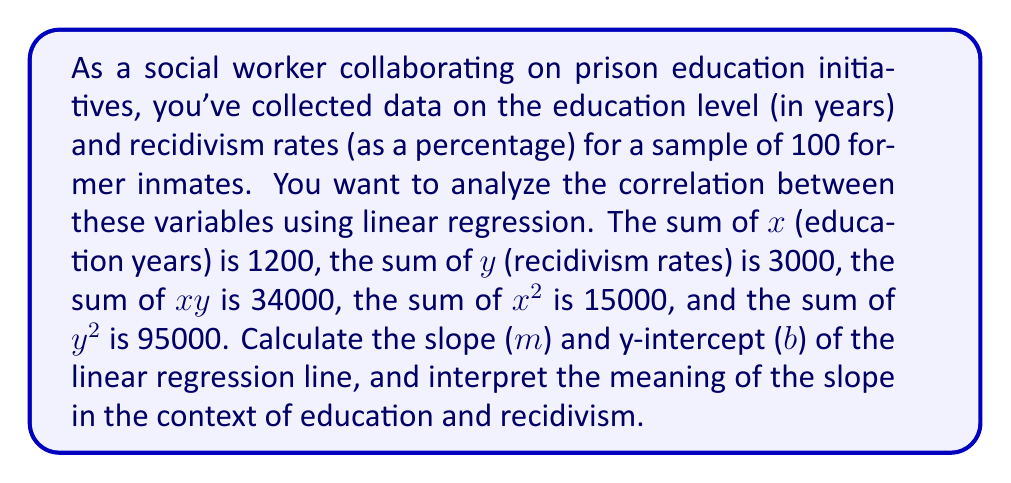Teach me how to tackle this problem. To find the slope (m) and y-intercept (b) of the linear regression line, we'll use the following formulas:

1. Slope (m):
   $$ m = \frac{n\sum xy - \sum x \sum y}{n\sum x^2 - (\sum x)^2} $$

2. Y-intercept (b):
   $$ b = \frac{\sum y - m\sum x}{n} $$

Where n is the number of data points (100 in this case).

Step 1: Calculate the slope (m)
$$ m = \frac{100(34000) - (1200)(3000)}{100(15000) - (1200)^2} $$
$$ m = \frac{3400000 - 3600000}{1500000 - 1440000} $$
$$ m = \frac{-200000}{60000} = -\frac{10}{3} \approx -3.33 $$

Step 2: Calculate the y-intercept (b)
$$ b = \frac{3000 - (-\frac{10}{3})(1200)}{100} $$
$$ b = \frac{3000 + 4000}{100} = \frac{7000}{100} = 70 $$

Interpretation of the slope:
The slope (m) represents the change in the recidivism rate for each additional year of education. In this case, the slope is negative, indicating an inverse relationship between education level and recidivism rate. Specifically, for each additional year of education, the recidivism rate is expected to decrease by approximately 3.33 percentage points.
Answer: Slope (m) = $-\frac{10}{3}$ or approximately -3.33
Y-intercept (b) = 70

The linear regression equation is:
$$ y = -\frac{10}{3}x + 70 $$

Interpretation: For each additional year of education, the recidivism rate is expected to decrease by approximately 3.33 percentage points. 